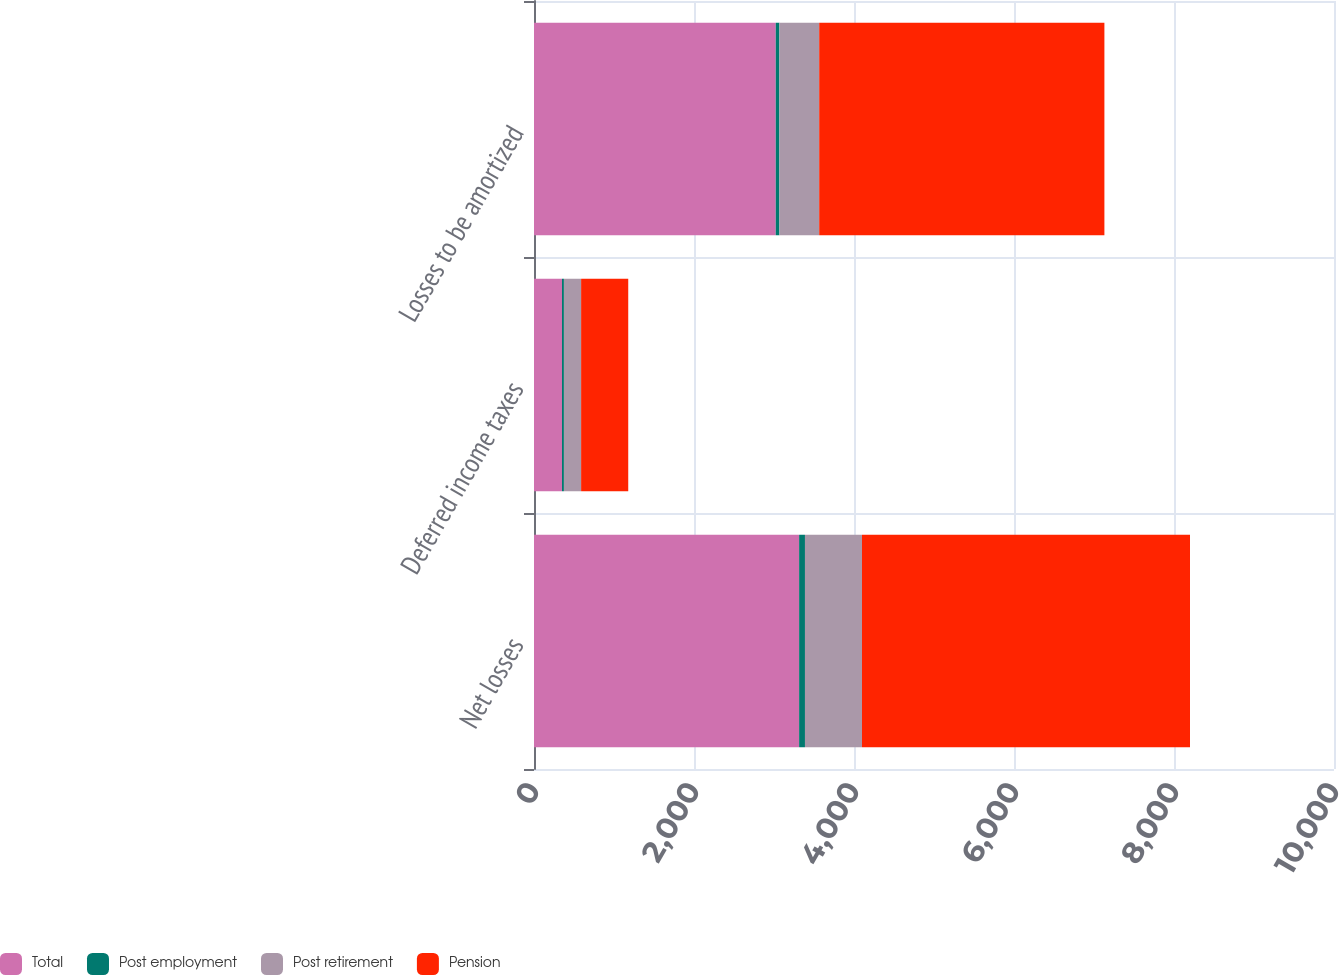<chart> <loc_0><loc_0><loc_500><loc_500><stacked_bar_chart><ecel><fcel>Net losses<fcel>Deferred income taxes<fcel>Losses to be amortized<nl><fcel>Total<fcel>3314<fcel>350<fcel>3022<nl><fcel>Post employment<fcel>73<fcel>24<fcel>45<nl><fcel>Post retirement<fcel>713<fcel>215<fcel>498<nl><fcel>Pension<fcel>4100<fcel>589<fcel>3565<nl></chart> 